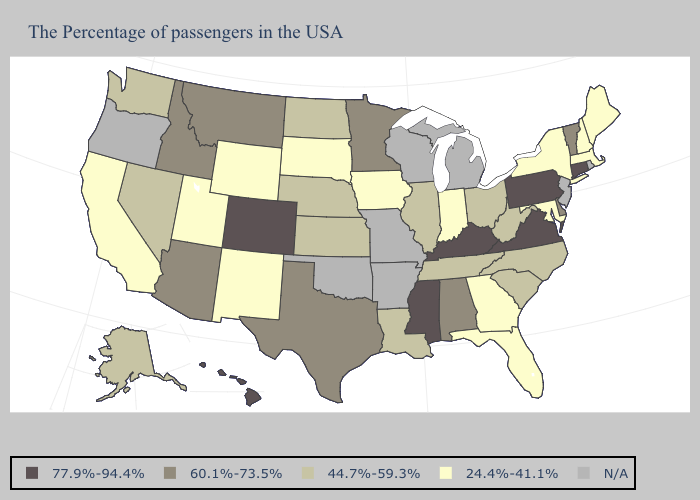Which states have the lowest value in the West?
Short answer required. Wyoming, New Mexico, Utah, California. Does Hawaii have the highest value in the West?
Be succinct. Yes. Name the states that have a value in the range 77.9%-94.4%?
Answer briefly. Connecticut, Pennsylvania, Virginia, Kentucky, Mississippi, Colorado, Hawaii. Among the states that border West Virginia , does Maryland have the lowest value?
Keep it brief. Yes. What is the lowest value in the USA?
Concise answer only. 24.4%-41.1%. Among the states that border Texas , does New Mexico have the highest value?
Give a very brief answer. No. Name the states that have a value in the range N/A?
Write a very short answer. Rhode Island, New Jersey, Michigan, Wisconsin, Missouri, Arkansas, Oklahoma, Oregon. Name the states that have a value in the range 77.9%-94.4%?
Be succinct. Connecticut, Pennsylvania, Virginia, Kentucky, Mississippi, Colorado, Hawaii. How many symbols are there in the legend?
Give a very brief answer. 5. Name the states that have a value in the range 60.1%-73.5%?
Short answer required. Vermont, Delaware, Alabama, Minnesota, Texas, Montana, Arizona, Idaho. Name the states that have a value in the range N/A?
Answer briefly. Rhode Island, New Jersey, Michigan, Wisconsin, Missouri, Arkansas, Oklahoma, Oregon. Among the states that border Montana , which have the lowest value?
Be succinct. South Dakota, Wyoming. What is the highest value in the USA?
Short answer required. 77.9%-94.4%. What is the lowest value in the South?
Concise answer only. 24.4%-41.1%. 